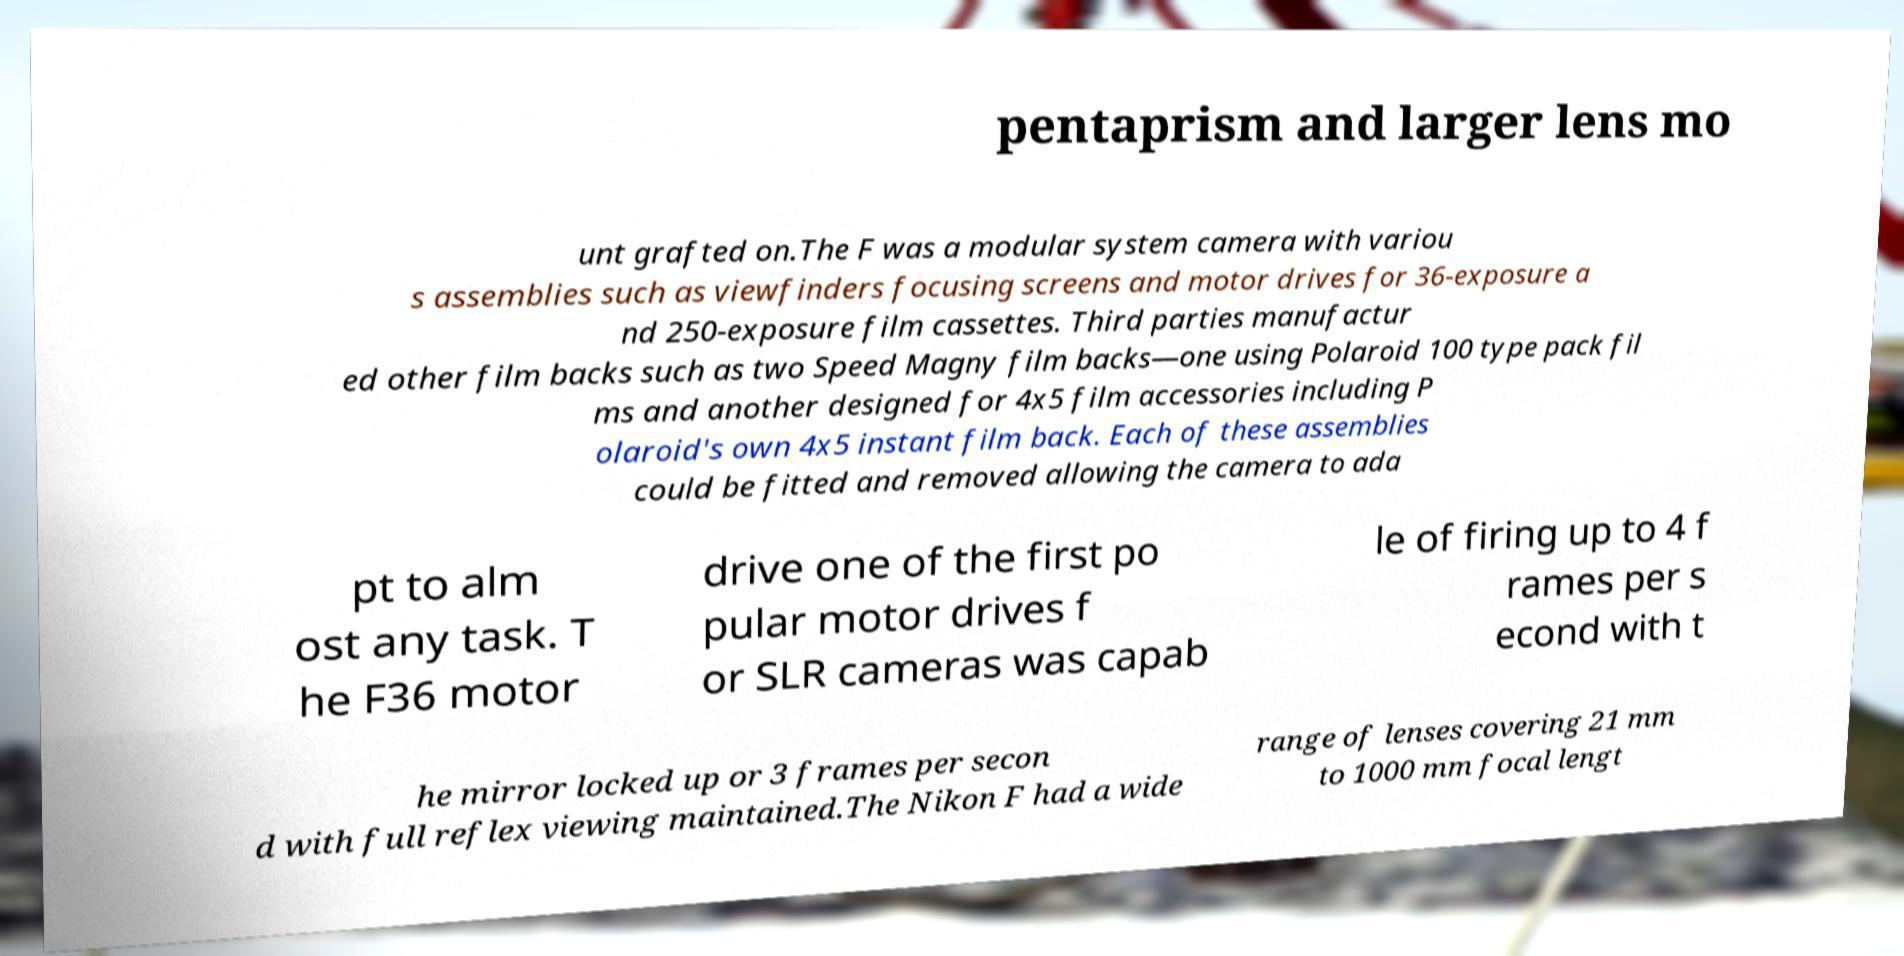I need the written content from this picture converted into text. Can you do that? pentaprism and larger lens mo unt grafted on.The F was a modular system camera with variou s assemblies such as viewfinders focusing screens and motor drives for 36-exposure a nd 250-exposure film cassettes. Third parties manufactur ed other film backs such as two Speed Magny film backs—one using Polaroid 100 type pack fil ms and another designed for 4x5 film accessories including P olaroid's own 4x5 instant film back. Each of these assemblies could be fitted and removed allowing the camera to ada pt to alm ost any task. T he F36 motor drive one of the first po pular motor drives f or SLR cameras was capab le of firing up to 4 f rames per s econd with t he mirror locked up or 3 frames per secon d with full reflex viewing maintained.The Nikon F had a wide range of lenses covering 21 mm to 1000 mm focal lengt 